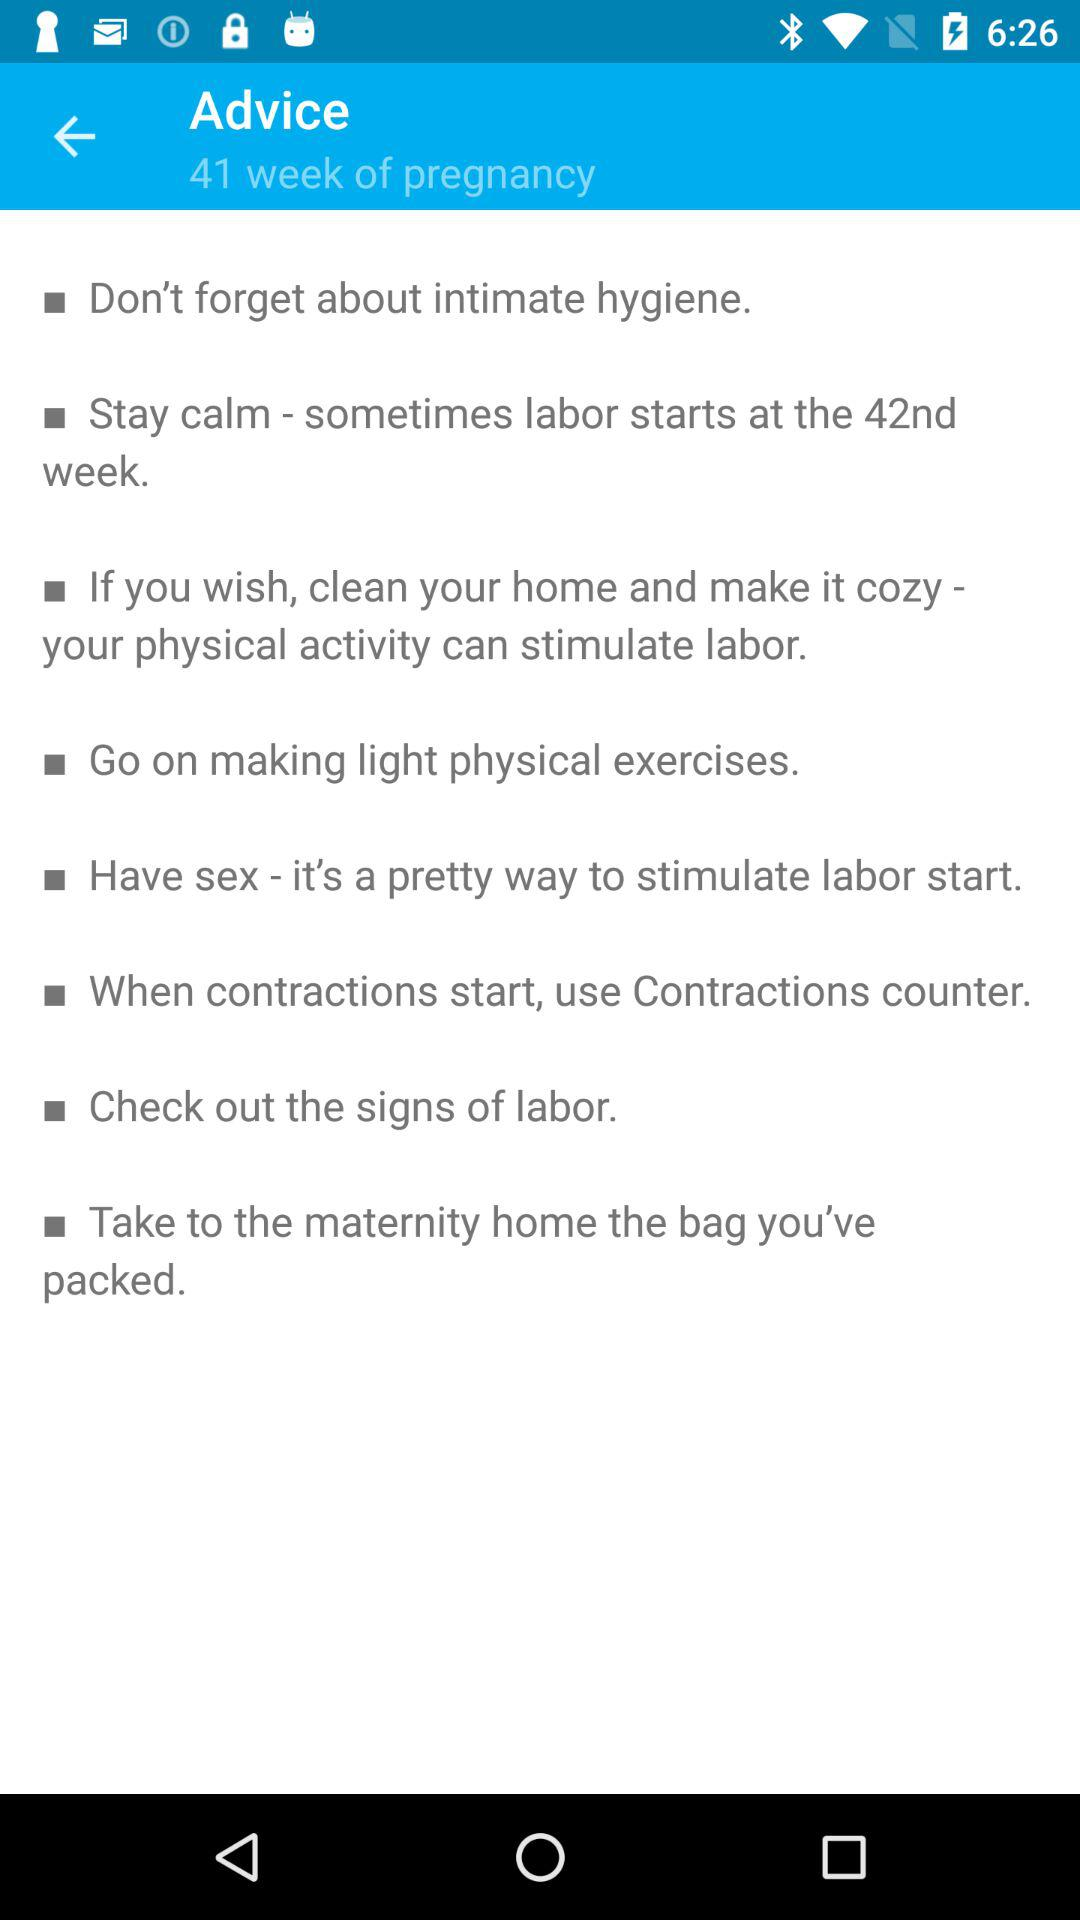How many tips are there for the 41st week?
Answer the question using a single word or phrase. 8 